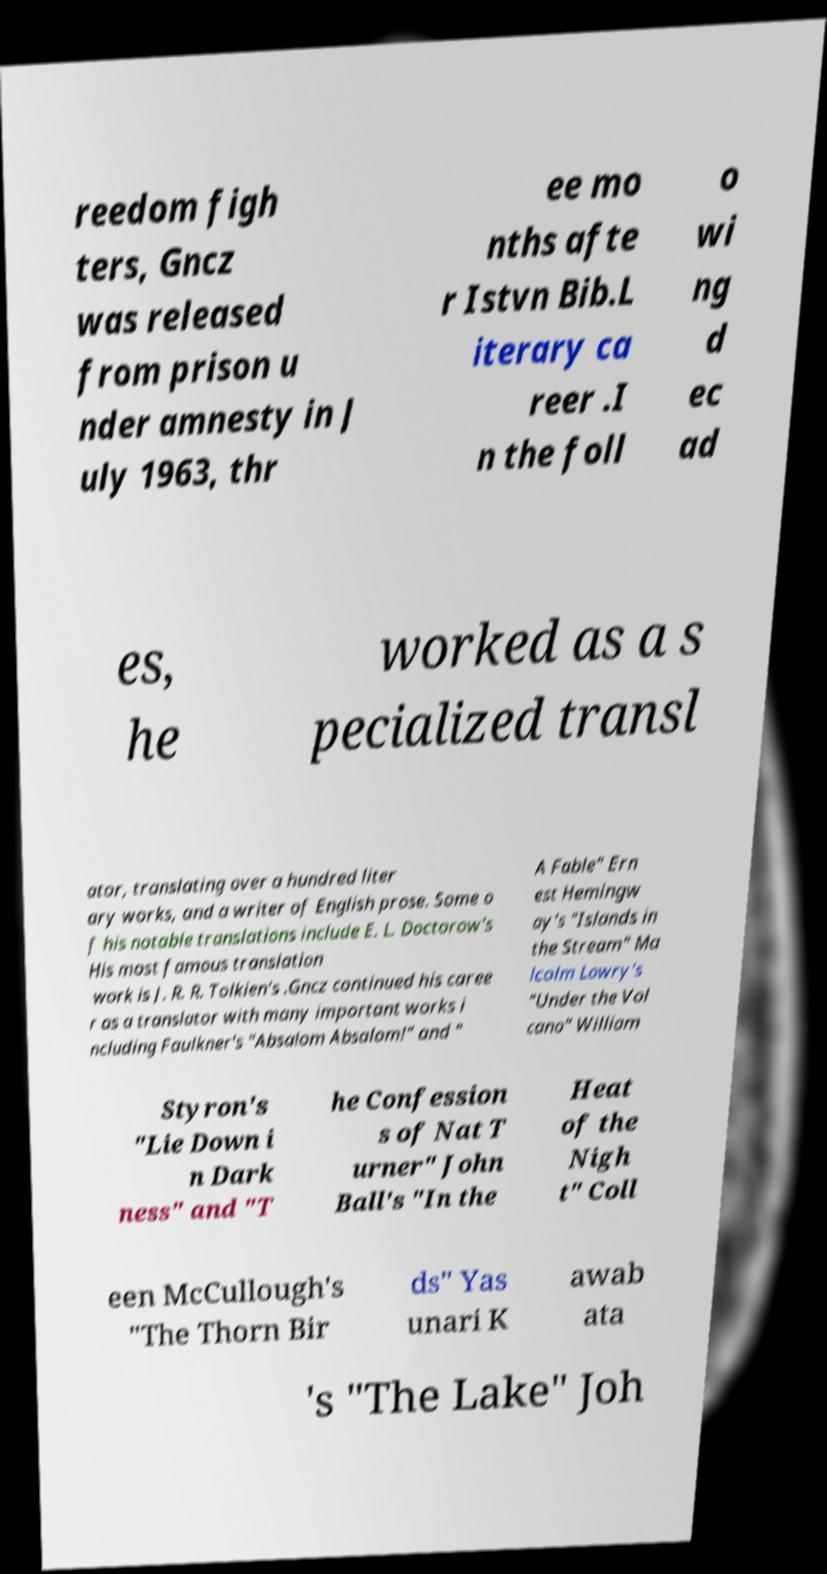Please identify and transcribe the text found in this image. reedom figh ters, Gncz was released from prison u nder amnesty in J uly 1963, thr ee mo nths afte r Istvn Bib.L iterary ca reer .I n the foll o wi ng d ec ad es, he worked as a s pecialized transl ator, translating over a hundred liter ary works, and a writer of English prose. Some o f his notable translations include E. L. Doctorow's His most famous translation work is J. R. R. Tolkien's .Gncz continued his caree r as a translator with many important works i ncluding Faulkner's "Absalom Absalom!" and " A Fable" Ern est Hemingw ay's "Islands in the Stream" Ma lcolm Lowry's "Under the Vol cano" William Styron's "Lie Down i n Dark ness" and "T he Confession s of Nat T urner" John Ball's "In the Heat of the Nigh t" Coll een McCullough's "The Thorn Bir ds" Yas unari K awab ata 's "The Lake" Joh 